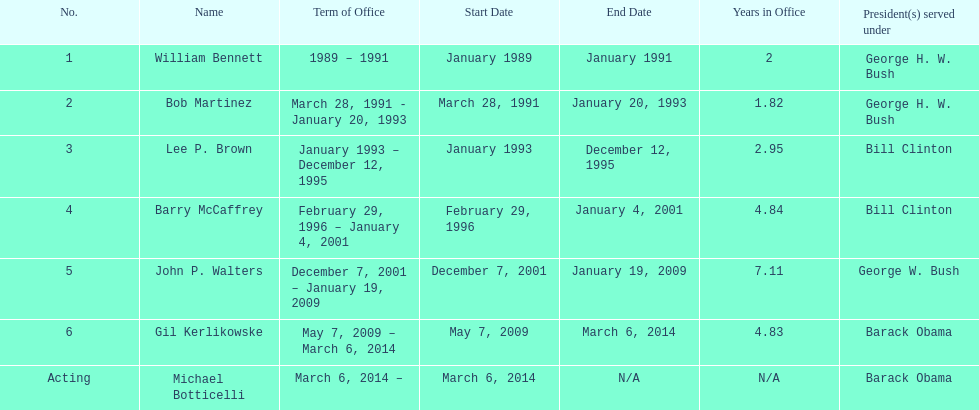When did john p. walters end his term? January 19, 2009. 